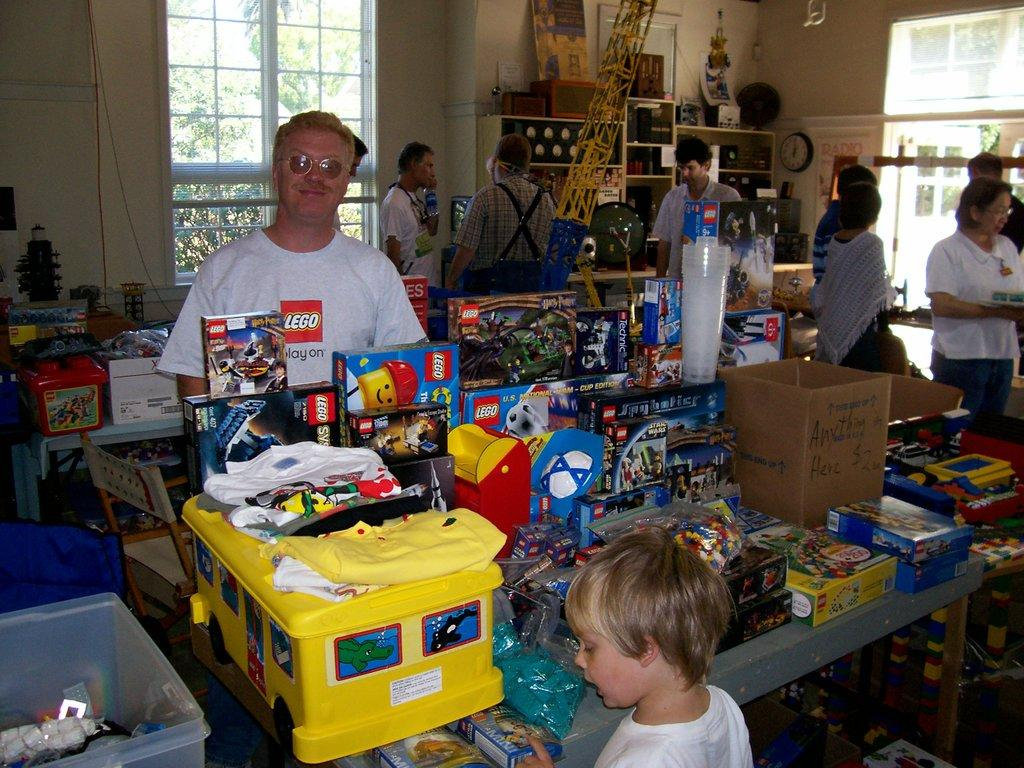What is the main subject of the image? The main subject of the image is a small boy. What can be seen on the table in the foreground area? There are toy boxes on a table in the foreground area. What is visible in the background of the image? In the background of the image, there are people, a clock, posters, other objects, a chair, toy boxes, windows, and trees. Can you describe the objects in the background of the image? The objects in the background of the image include a clock, posters, other objects, a chair, toy boxes, windows, and trees. What type of soda is being poured from the bottle in the image? There is no bottle or soda present in the image. What substance is being used to clean the chair in the image? There is no cleaning substance or activity involving the chair in the image. 